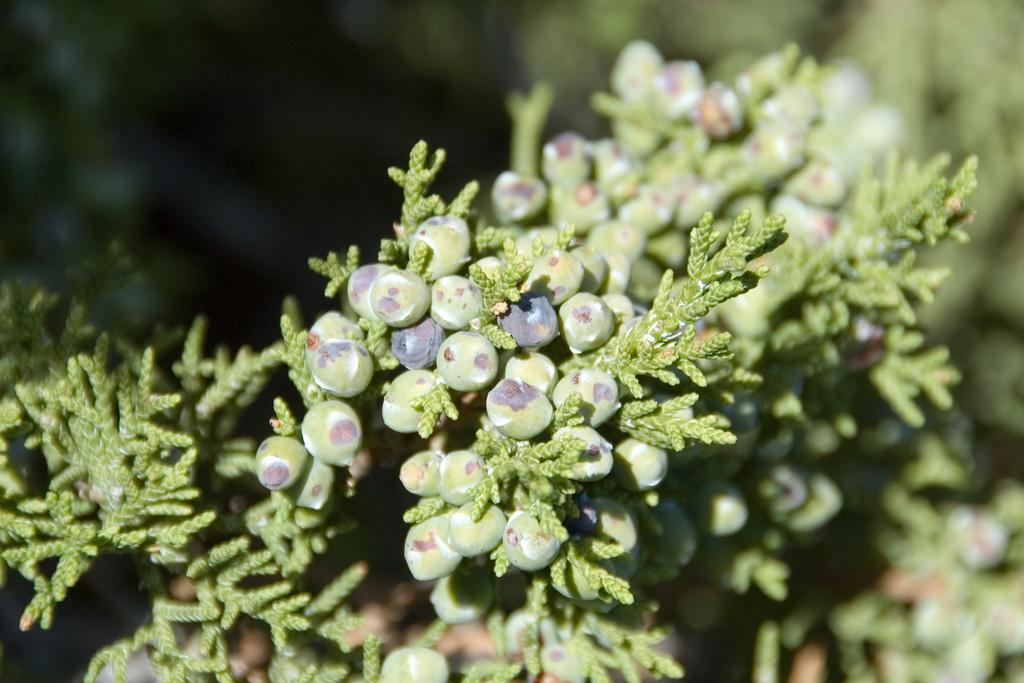What type of living organisms can be seen in the image? Plants can be seen in the image. What is the color of the plants in the image? The plants are green in color. What else can be seen on the plants? There are fruits on the plants. What is the color of the fruits on the plants? The fruits are green and black in color. How would you describe the background of the image? The background of the image is blurry. What type of scent can be detected from the plants in the image? There is no information about the scent of the plants in the image, so it cannot be determined. 